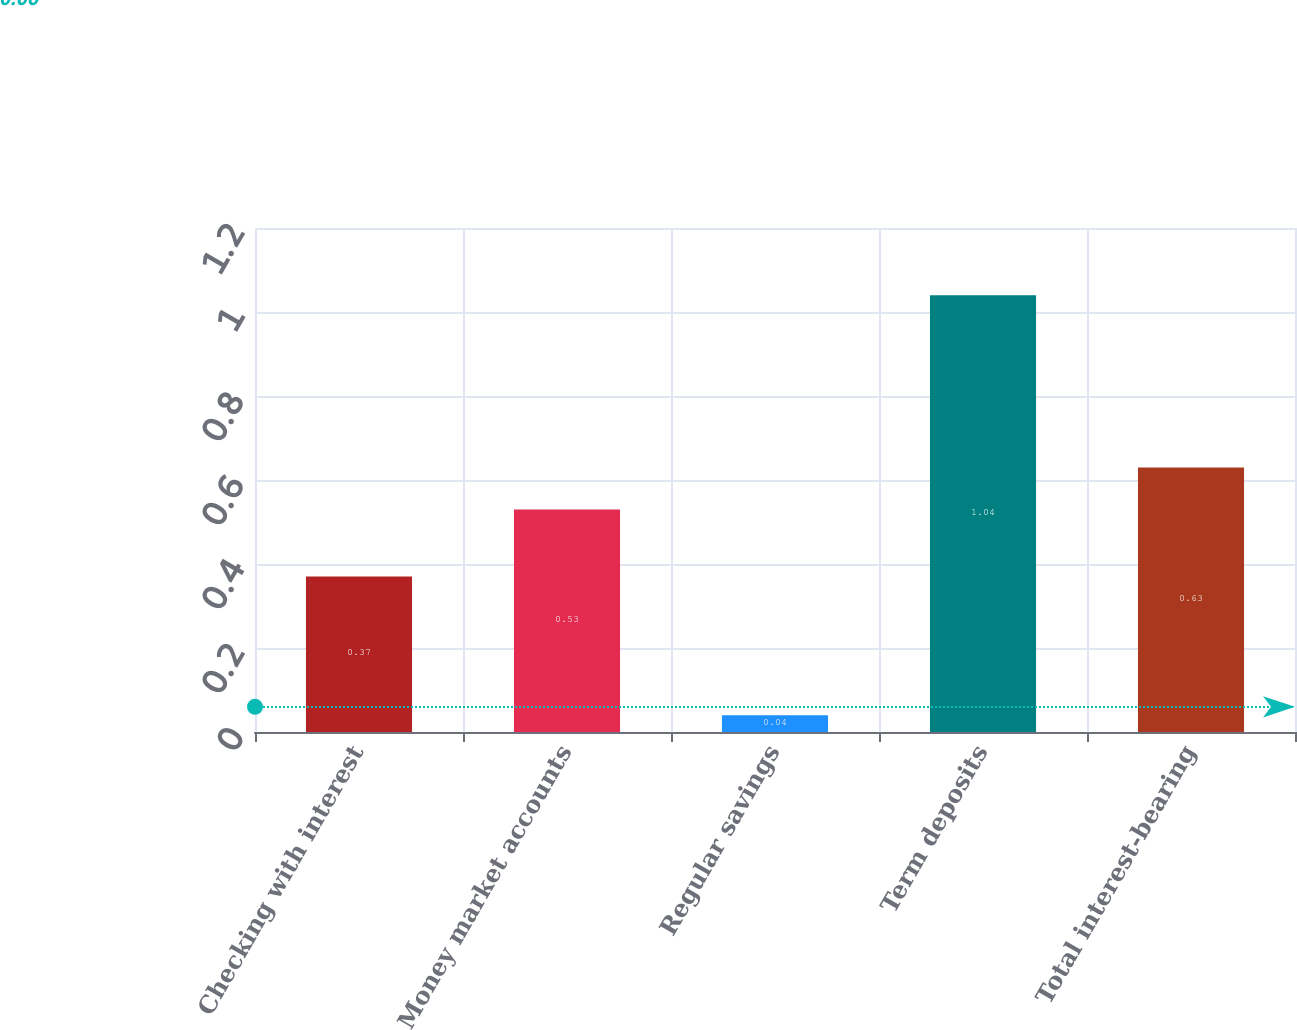<chart> <loc_0><loc_0><loc_500><loc_500><bar_chart><fcel>Checking with interest<fcel>Money market accounts<fcel>Regular savings<fcel>Term deposits<fcel>Total interest-bearing<nl><fcel>0.37<fcel>0.53<fcel>0.04<fcel>1.04<fcel>0.63<nl></chart> 